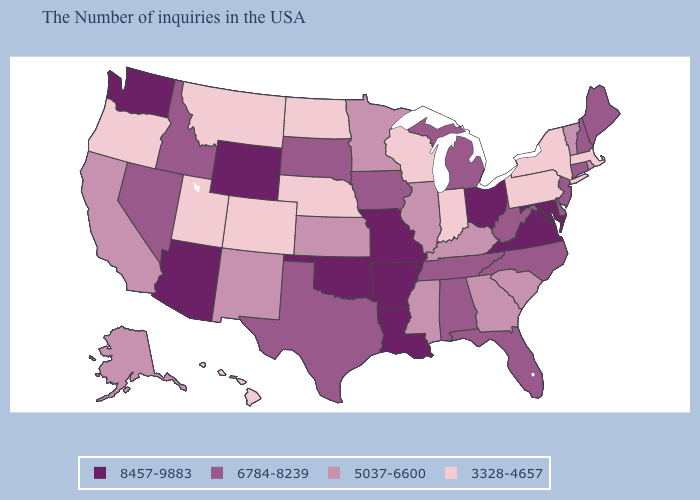Which states have the lowest value in the USA?
Concise answer only. Massachusetts, New York, Pennsylvania, Indiana, Wisconsin, Nebraska, North Dakota, Colorado, Utah, Montana, Oregon, Hawaii. Does New York have a lower value than Utah?
Answer briefly. No. What is the value of Oregon?
Be succinct. 3328-4657. Which states have the lowest value in the USA?
Concise answer only. Massachusetts, New York, Pennsylvania, Indiana, Wisconsin, Nebraska, North Dakota, Colorado, Utah, Montana, Oregon, Hawaii. What is the value of Mississippi?
Answer briefly. 5037-6600. What is the value of Mississippi?
Quick response, please. 5037-6600. Name the states that have a value in the range 3328-4657?
Keep it brief. Massachusetts, New York, Pennsylvania, Indiana, Wisconsin, Nebraska, North Dakota, Colorado, Utah, Montana, Oregon, Hawaii. Name the states that have a value in the range 6784-8239?
Write a very short answer. Maine, New Hampshire, Connecticut, New Jersey, Delaware, North Carolina, West Virginia, Florida, Michigan, Alabama, Tennessee, Iowa, Texas, South Dakota, Idaho, Nevada. Does the map have missing data?
Be succinct. No. What is the value of New Hampshire?
Concise answer only. 6784-8239. What is the value of Delaware?
Write a very short answer. 6784-8239. Name the states that have a value in the range 3328-4657?
Give a very brief answer. Massachusetts, New York, Pennsylvania, Indiana, Wisconsin, Nebraska, North Dakota, Colorado, Utah, Montana, Oregon, Hawaii. Name the states that have a value in the range 8457-9883?
Concise answer only. Maryland, Virginia, Ohio, Louisiana, Missouri, Arkansas, Oklahoma, Wyoming, Arizona, Washington. Among the states that border Alabama , does Mississippi have the highest value?
Answer briefly. No. Name the states that have a value in the range 8457-9883?
Short answer required. Maryland, Virginia, Ohio, Louisiana, Missouri, Arkansas, Oklahoma, Wyoming, Arizona, Washington. 